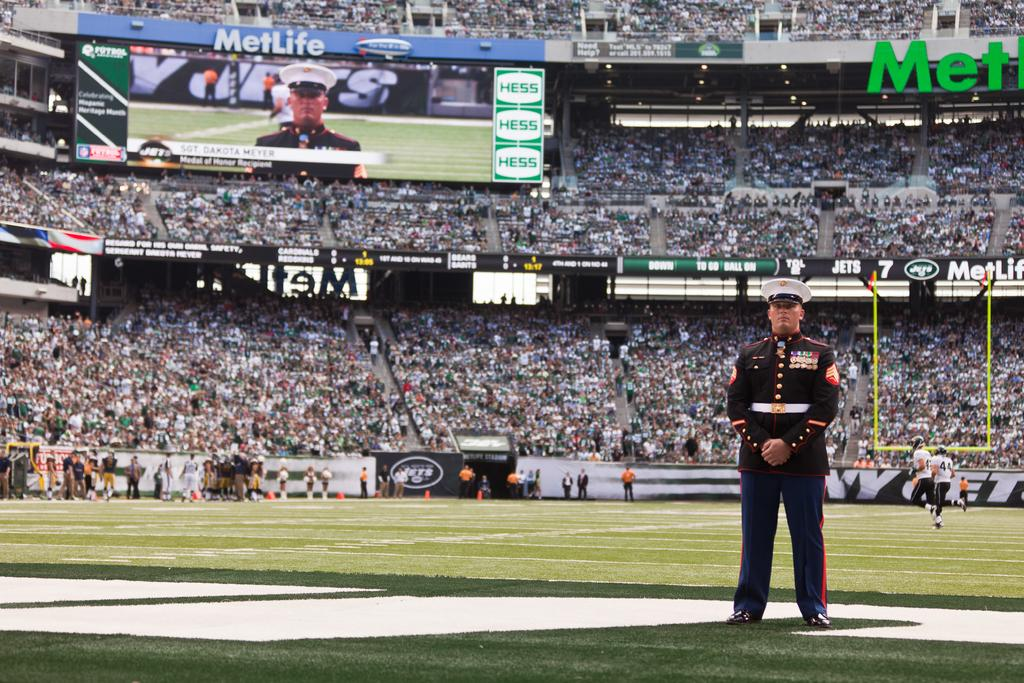<image>
Relay a brief, clear account of the picture shown. a soldier on a baseball field with a giant screen for MetLife behind him 